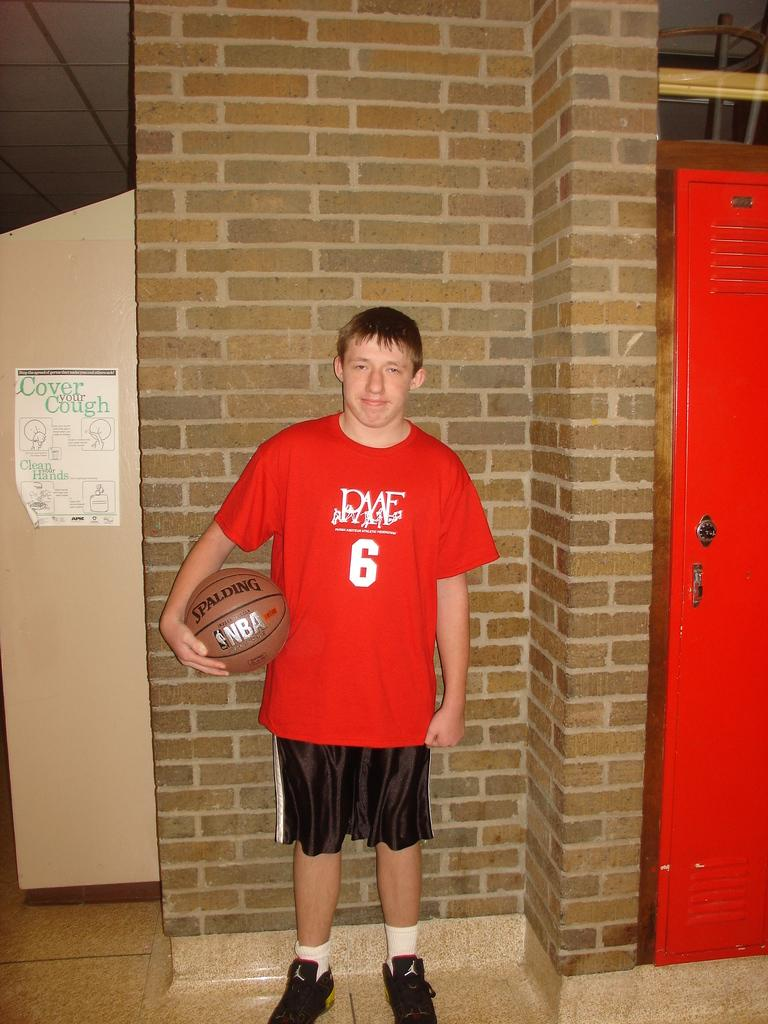Provide a one-sentence caption for the provided image. A very saturated shot of basketball player number 6 against a brick wall. 